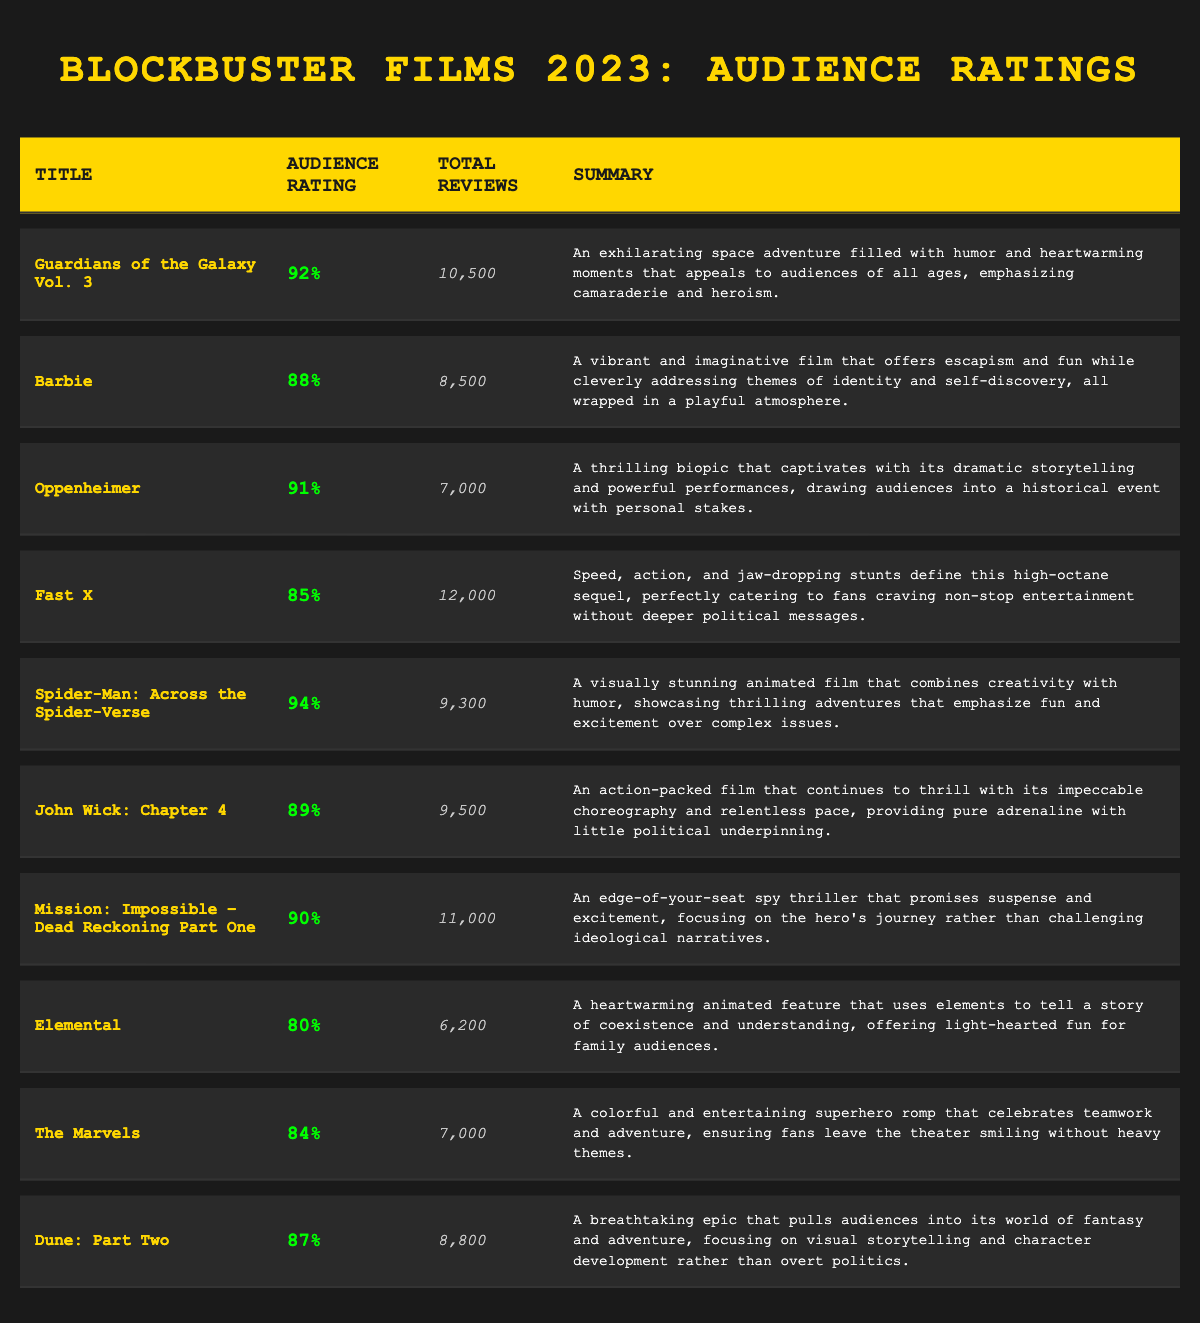What is the audience rating for "Spider-Man: Across the Spider-Verse"? The table lists "Spider-Man: Across the Spider-Verse" with an audience rating of 94%.
Answer: 94% Which film had the highest number of total reviews? By reviewing the total reviews column, "Fast X" has the highest count with 12,000 reviews, making it the film with the most reviews.
Answer: Fast X What is the average audience rating of all films listed? First, sum the audience ratings: (92 + 88 + 91 + 85 + 94 + 89 + 90 + 80 + 84 + 87) = 900. Next, divide this by the number of films, which is 10. So, 900/10 = 90.
Answer: 90 Did "Oppenheimer" receive a higher audience rating than "Barbie"? "Oppenheimer" has an audience rating of 91%, while "Barbie" has a rating of 88%. Since 91% is greater than 88%, the answer is yes.
Answer: Yes Which films have an audience rating greater than 90%? By checking the ratings, the films with ratings greater than 90% are "Spider-Man: Across the Spider-Verse" (94%), "Guardians of the Galaxy Vol. 3" (92%), and "Oppenheimer" (91%).
Answer: Spider-Man: Across the Spider-Verse, Guardians of the Galaxy Vol. 3, Oppenheimer What is the difference in the audience ratings between "Fast X" and "Elemental"? "Fast X" has an audience rating of 85%, while "Elemental" has 80%. The difference is calculated by subtracting: 85% - 80% = 5%.
Answer: 5% What percentage of reviews did "John Wick: Chapter 4" receive compared to "Mission: Impossible – Dead Reckoning Part One"? "John Wick: Chapter 4" received 9,500 reviews, and "Mission: Impossible – Dead Reckoning Part One" received 11,000 reviews. To find the percentage: (9,500 / 11,000) * 100 = 86.36%.
Answer: 86.36% Are there any films in the table with an audience rating below 85%? Checking the ratings, "Elemental" has an audience rating of 80%, which is below 85%. Therefore, the answer is yes.
Answer: Yes Which film has the most positive summary focusing on entertainment? Reviewing the summaries, "Fast X" particularly emphasizes non-stop entertainment without deeper political messages. It is focused purely on entertainment.
Answer: Fast X 